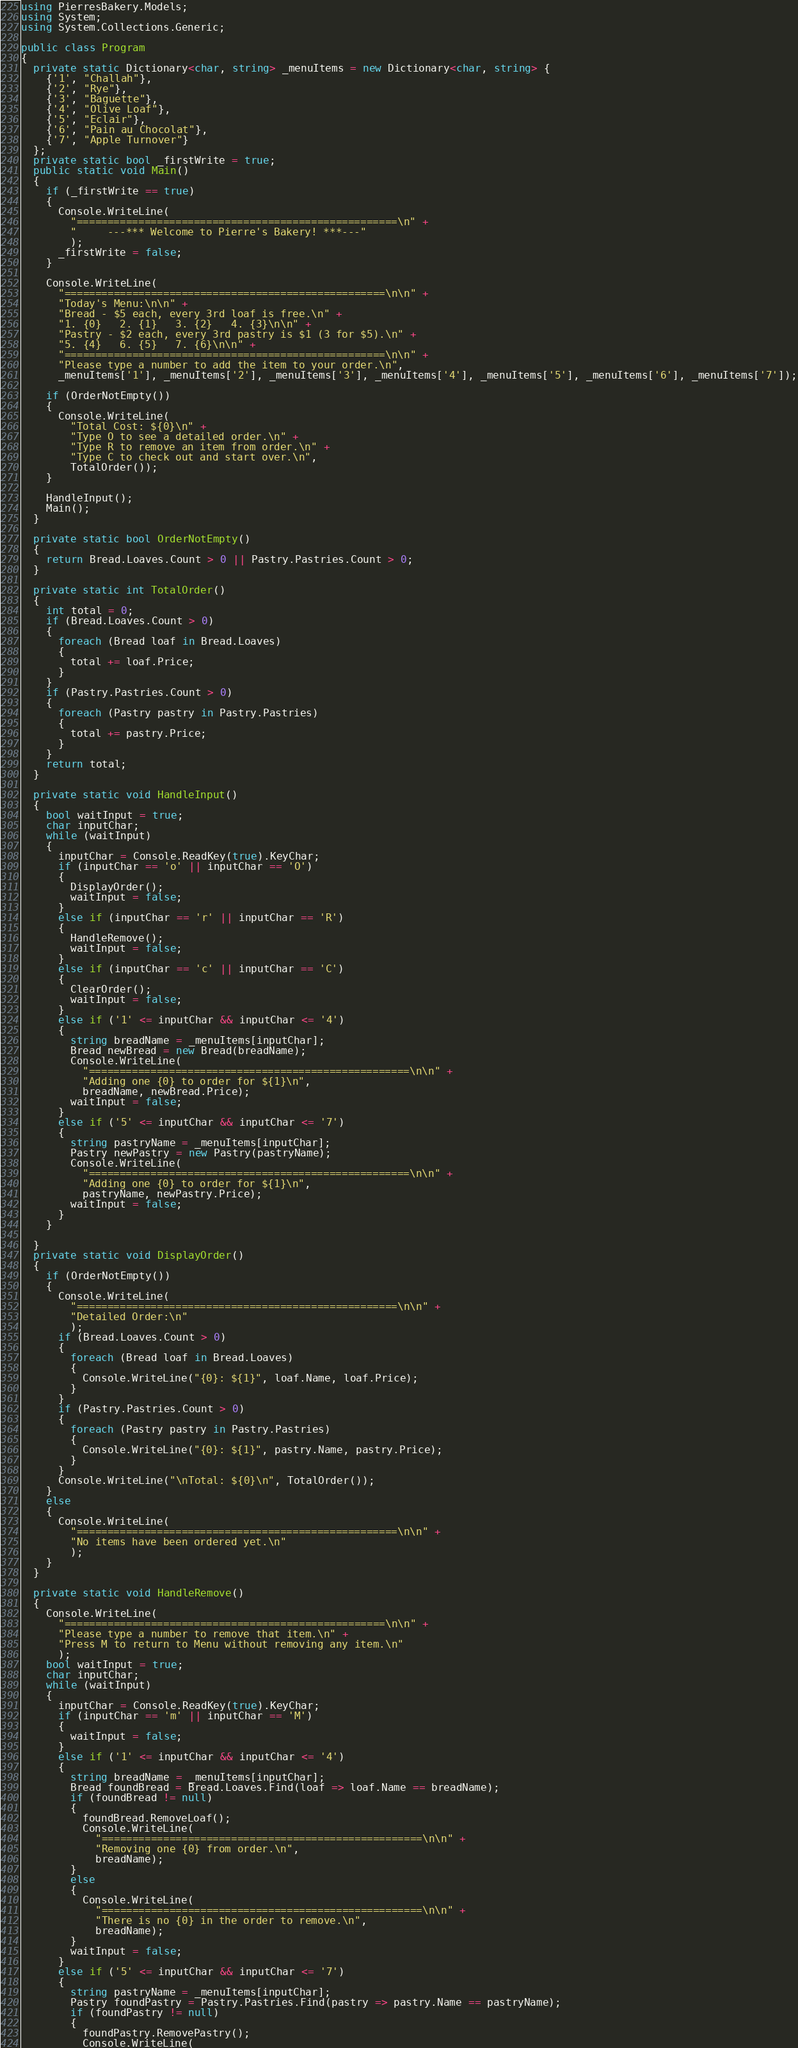<code> <loc_0><loc_0><loc_500><loc_500><_C#_>using PierresBakery.Models;
using System;
using System.Collections.Generic;

public class Program
{
  private static Dictionary<char, string> _menuItems = new Dictionary<char, string> {
    {'1', "Challah"},
    {'2', "Rye"},
    {'3', "Baguette"},
    {'4', "Olive Loaf"},
    {'5', "Eclair"},
    {'6', "Pain au Chocolat"},
    {'7', "Apple Turnover"}
  };
  private static bool _firstWrite = true;
  public static void Main()
  {
    if (_firstWrite == true)
    {
      Console.WriteLine(
        "====================================================\n" +
        "     ---*** Welcome to Pierre's Bakery! ***---"
        );
      _firstWrite = false;
    }

    Console.WriteLine(
      "====================================================\n\n" +
      "Today's Menu:\n\n" +
      "Bread - $5 each, every 3rd loaf is free.\n" +
      "1. {0}   2. {1}   3. {2}   4. {3}\n\n" +
      "Pastry - $2 each, every 3rd pastry is $1 (3 for $5).\n" +
      "5. {4}   6. {5}   7. {6}\n\n" +
      "====================================================\n\n" +
      "Please type a number to add the item to your order.\n",
      _menuItems['1'], _menuItems['2'], _menuItems['3'], _menuItems['4'], _menuItems['5'], _menuItems['6'], _menuItems['7']);
    
    if (OrderNotEmpty())
    {
      Console.WriteLine(
        "Total Cost: ${0}\n" +
        "Type O to see a detailed order.\n" +
        "Type R to remove an item from order.\n" +
        "Type C to check out and start over.\n",
        TotalOrder());
    }

    HandleInput();
    Main();
  }

  private static bool OrderNotEmpty()
  {
    return Bread.Loaves.Count > 0 || Pastry.Pastries.Count > 0;
  }

  private static int TotalOrder()
  {
    int total = 0;
    if (Bread.Loaves.Count > 0)
    {
      foreach (Bread loaf in Bread.Loaves)
      {
        total += loaf.Price;
      } 
    }
    if (Pastry.Pastries.Count > 0)
    {
      foreach (Pastry pastry in Pastry.Pastries)
      {
        total += pastry.Price;
      } 
    }
    return total;
  }

  private static void HandleInput()
  {
    bool waitInput = true;
    char inputChar;
    while (waitInput)
    {
      inputChar = Console.ReadKey(true).KeyChar;
      if (inputChar == 'o' || inputChar == 'O')
      {
        DisplayOrder();
        waitInput = false;
      }
      else if (inputChar == 'r' || inputChar == 'R')
      {
        HandleRemove();
        waitInput = false;
      }
      else if (inputChar == 'c' || inputChar == 'C')
      {
        ClearOrder();
        waitInput = false;
      }
      else if ('1' <= inputChar && inputChar <= '4')
      {
        string breadName = _menuItems[inputChar];
        Bread newBread = new Bread(breadName);
        Console.WriteLine(
          "====================================================\n\n" +
          "Adding one {0} to order for ${1}\n", 
          breadName, newBread.Price);
        waitInput = false;
      }
      else if ('5' <= inputChar && inputChar <= '7')
      {
        string pastryName = _menuItems[inputChar];
        Pastry newPastry = new Pastry(pastryName);
        Console.WriteLine(
          "====================================================\n\n" +
          "Adding one {0} to order for ${1}\n",
          pastryName, newPastry.Price);
        waitInput = false;
      }
    }
    
  }
  private static void DisplayOrder()
  {
    if (OrderNotEmpty())
    {
      Console.WriteLine(
        "====================================================\n\n" +
        "Detailed Order:\n"
        );
      if (Bread.Loaves.Count > 0)
      {
        foreach (Bread loaf in Bread.Loaves)
        {
          Console.WriteLine("{0}: ${1}", loaf.Name, loaf.Price);
        } 
      }
      if (Pastry.Pastries.Count > 0)
      {
        foreach (Pastry pastry in Pastry.Pastries)
        {
          Console.WriteLine("{0}: ${1}", pastry.Name, pastry.Price);
        } 
      }
      Console.WriteLine("\nTotal: ${0}\n", TotalOrder());
    }
    else
    {
      Console.WriteLine(
        "====================================================\n\n" +
        "No items have been ordered yet.\n"
        );
    }
  }

  private static void HandleRemove()
  {
    Console.WriteLine(
      "====================================================\n\n" +
      "Please type a number to remove that item.\n" +
      "Press M to return to Menu without removing any item.\n"
      );
    bool waitInput = true;
    char inputChar;
    while (waitInput)
    {
      inputChar = Console.ReadKey(true).KeyChar;
      if (inputChar == 'm' || inputChar == 'M')
      {
        waitInput = false;
      }
      else if ('1' <= inputChar && inputChar <= '4')
      {
        string breadName = _menuItems[inputChar];
        Bread foundBread = Bread.Loaves.Find(loaf => loaf.Name == breadName);
        if (foundBread != null)
        {
          foundBread.RemoveLoaf();
          Console.WriteLine(
            "====================================================\n\n" +
            "Removing one {0} from order.\n",
            breadName);
        }
        else
        {
          Console.WriteLine(
            "====================================================\n\n" +
            "There is no {0} in the order to remove.\n",
            breadName);
        }
        waitInput = false; 
      }
      else if ('5' <= inputChar && inputChar <= '7')
      {
        string pastryName = _menuItems[inputChar];
        Pastry foundPastry = Pastry.Pastries.Find(pastry => pastry.Name == pastryName);
        if (foundPastry != null)
        {
          foundPastry.RemovePastry();
          Console.WriteLine(</code> 